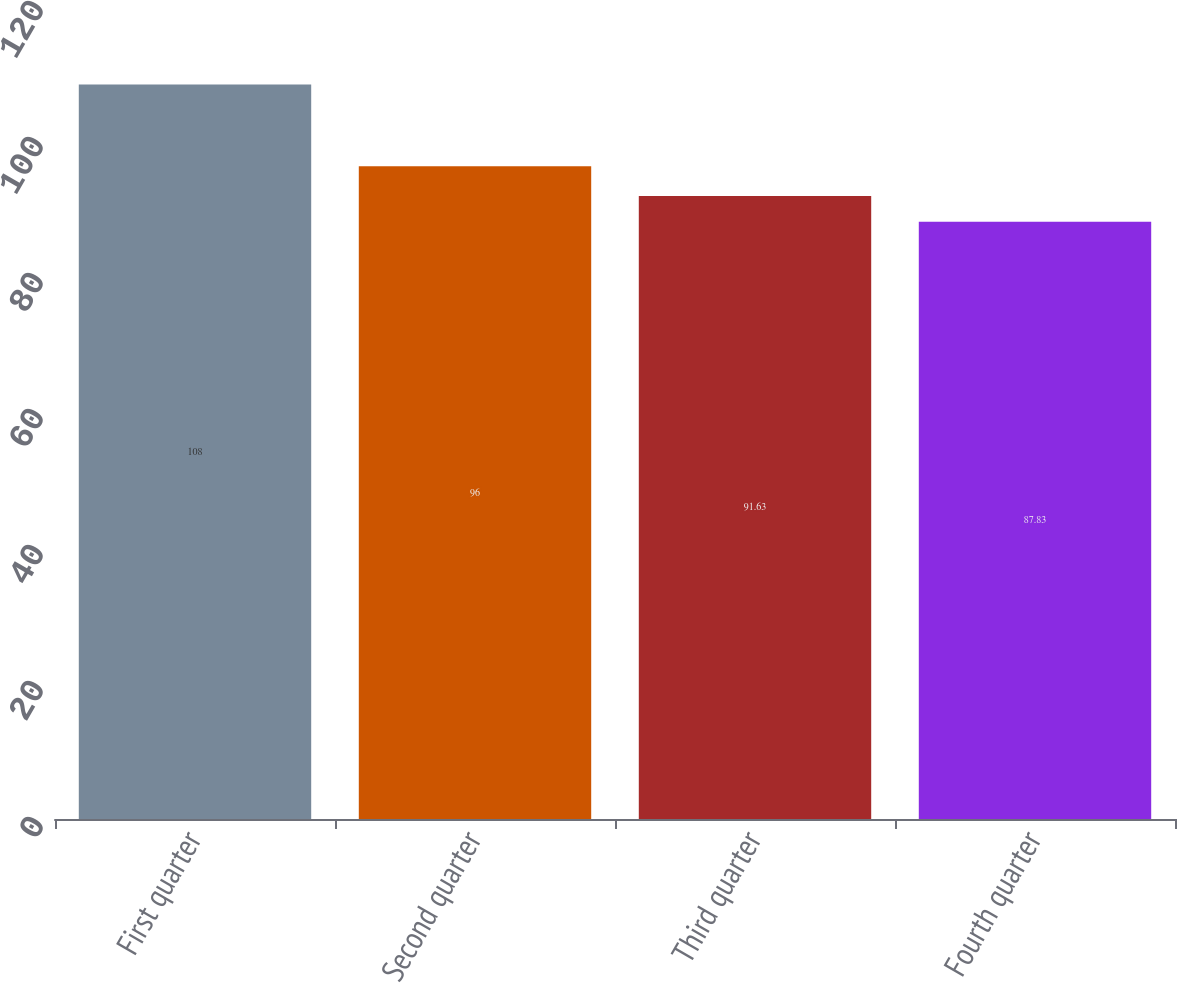<chart> <loc_0><loc_0><loc_500><loc_500><bar_chart><fcel>First quarter<fcel>Second quarter<fcel>Third quarter<fcel>Fourth quarter<nl><fcel>108<fcel>96<fcel>91.63<fcel>87.83<nl></chart> 